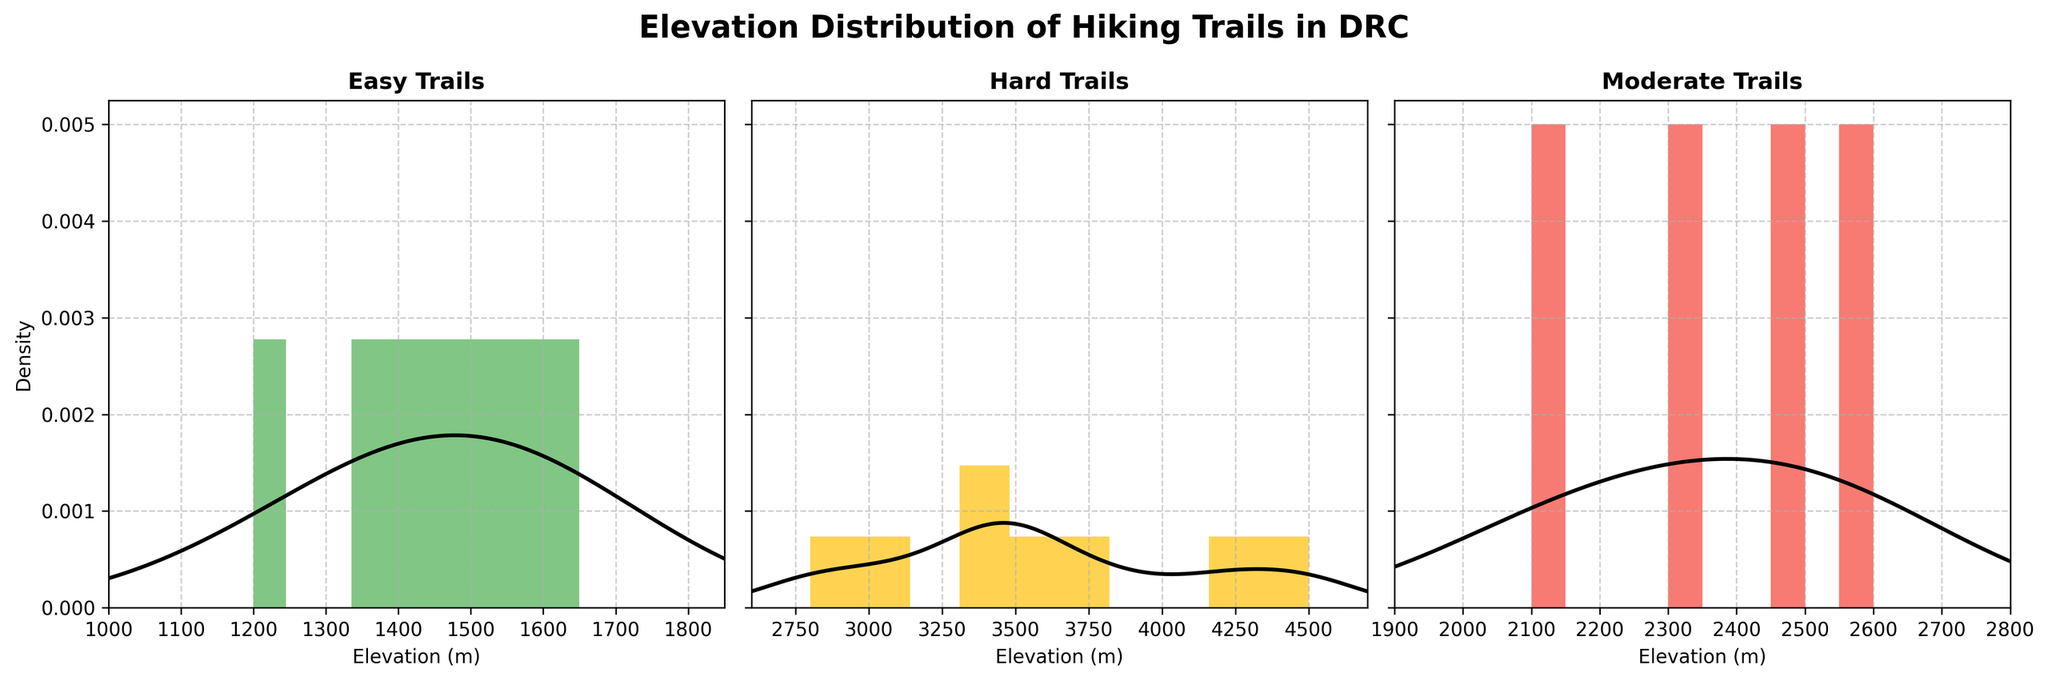what is the title of the figure? The title of the figure is typically placed at the top and describes what the entire figure is about. Here, it is given as 'Elevation Distribution of Hiking Trails in DRC'.
Answer: Elevation Distribution of Hiking Trails in DRC Which color represents the 'Hard' trails? The color representing each difficulty level is separated clearly by different colors. By looking at the color schema and identifying which label matches 'Hard', we see that it is represented by a red color.
Answer: red Which difficulty level has trails with the lowest elevation? By comparing the lowest elevation shown in each subplot, the 'Easy' trails have the elevation range starting around 1200 meters. This is lower compared to the 'Moderate' and 'Hard' difficulty trails.
Answer: Easy What’s the range of elevation for 'Easy' trails? Observing the start and end points of the 'Easy' trails on the x-axis indicates they range from about 1200 meters to 1650 meters.
Answer: 1200 to 1650 meters Which difficulty level shows the widest range of elevations? We need to observe the x-axis limits for each difficulty level. 'Hard' trails show the widest range from about 2800 to 4500 meters.
Answer: Hard Are there any difficulty levels that share an elevation value, and if so which ones? Checking overlaps in elevation distributions, it's apparent that there is some shared elevation between 'Moderate' and 'Hard' trails around the 2800 - 3100 meters range.
Answer: Moderate and Hard Which density curve appears to have the highest peak? The density curve with the highest peak is the one that reaches the highest value on the y-axis. Observing the subplots, the 'Easy' trails have the highest peak.
Answer: Easy What is the approximate maximum elevation of the 'Moderate' trails? By looking at the farthest right point on the x-axis in the 'Moderate' category, the maximum elevation value is around 2600 meters.
Answer: 2600 meters Between 'Moderate' and 'Hard' trails, which one has a higher median elevation? The median can be roughly estimated by looking at the middle of the elevation range for each category. 'Hard' trails have a higher median as they are distributed from 2800 to 4500 meters, while 'Moderate' trails are from 2100 to 2600 meters.
Answer: Hard Comparing 'Easy' and 'Hard' trails, which one has a more spread-out distribution? The spread of the distribution can be observed by the width of the elevation range. 'Hard' trails have a more spread-out distribution compared to 'Easy' trails.
Answer: Hard 